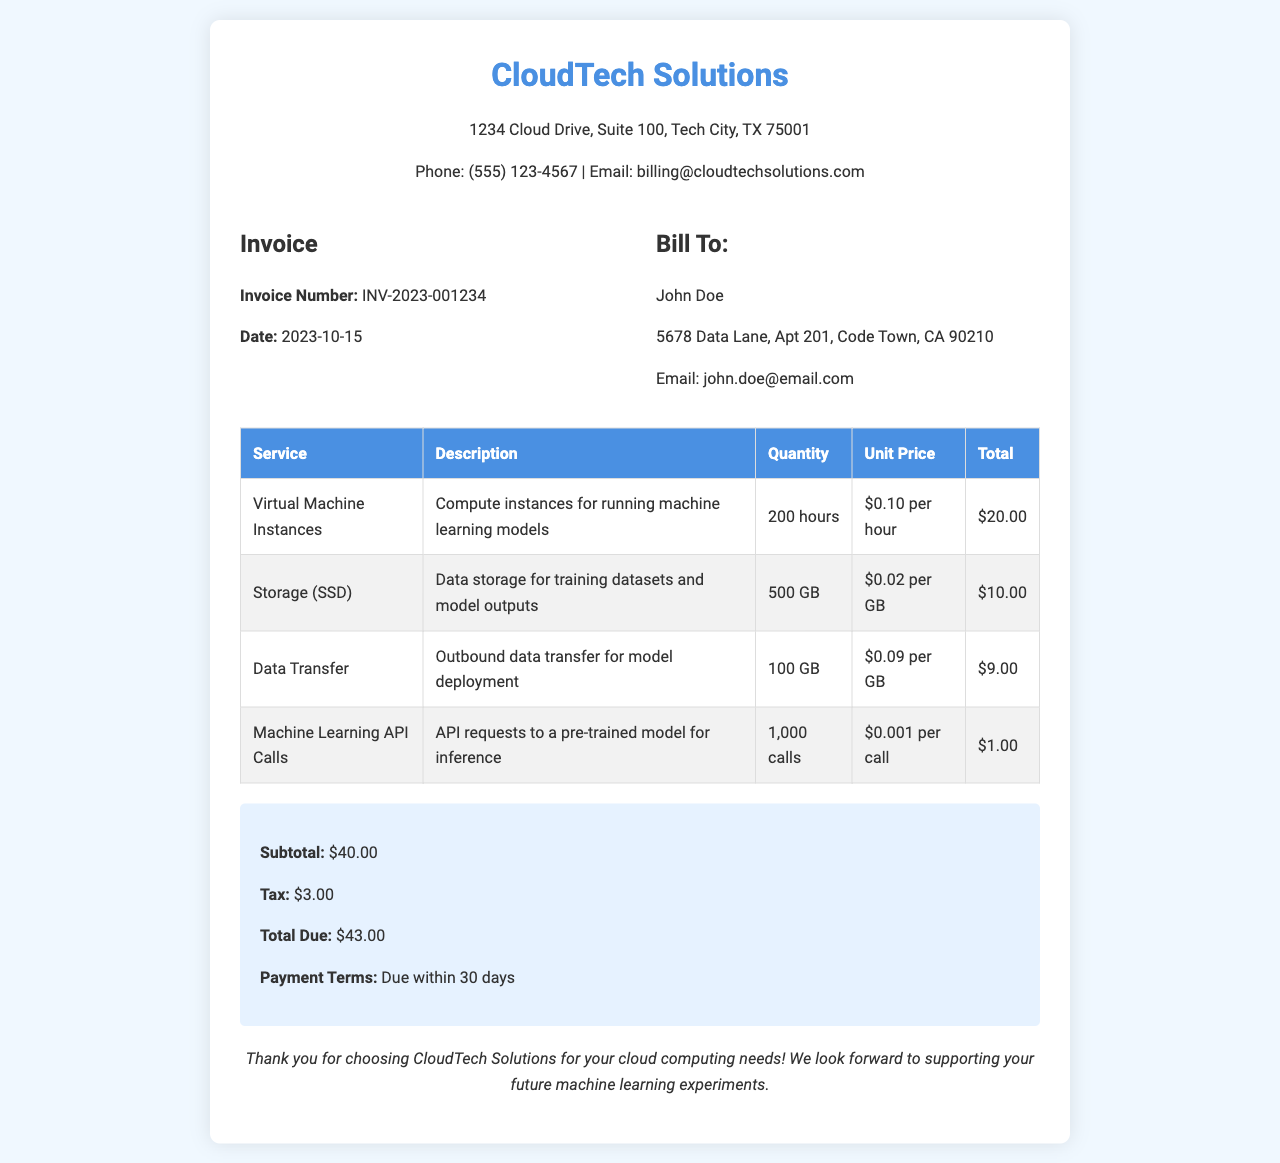What is the invoice number? The invoice number is provided in the header section of the document, specifying unique identification for the invoice.
Answer: INV-2023-001234 What is the date of the invoice? The date of the invoice is listed in the invoice details, indicating when it was issued.
Answer: 2023-10-15 Who is the bill to? The "Bill To" section identifies the customer receiving the invoice.
Answer: John Doe What is the total due amount? The total due is summarized at the end of the document, reflecting the complete bill to be paid.
Answer: $43.00 How much was charged for virtual machine instances? The total for virtual machine instances is detailed in the service breakdown, indicating how much was billed for this service.
Answer: $20.00 What is the quantity of storage (SSD) used? The quantity of storage used is noted in the service breakdown, specifying the amount of storage charged.
Answer: 500 GB What is the subtotal before tax? The subtotal is provided in the summary section, representing the cost of services before additional fees.
Answer: $40.00 What is the unit price for machine learning API calls? The unit price for machine learning API calls is listed next to the specific service in the table, indicating the charge per individual call.
Answer: $0.001 per call What is the payment term for this invoice? The payment term is mentioned in the summary, outlining how long the customer has to make the payment.
Answer: Due within 30 days 